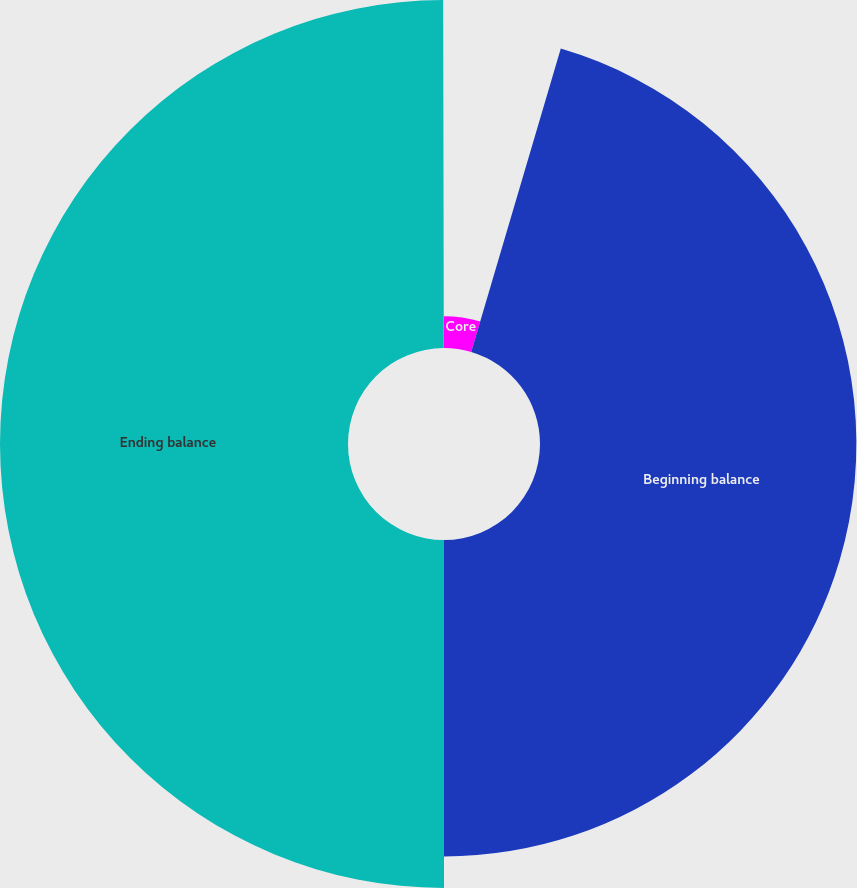<chart> <loc_0><loc_0><loc_500><loc_500><pie_chart><fcel>Core<fcel>Beginning balance<fcel>Ending balance<fcel>Goodwill adjustments related<nl><fcel>4.57%<fcel>45.43%<fcel>49.97%<fcel>0.03%<nl></chart> 